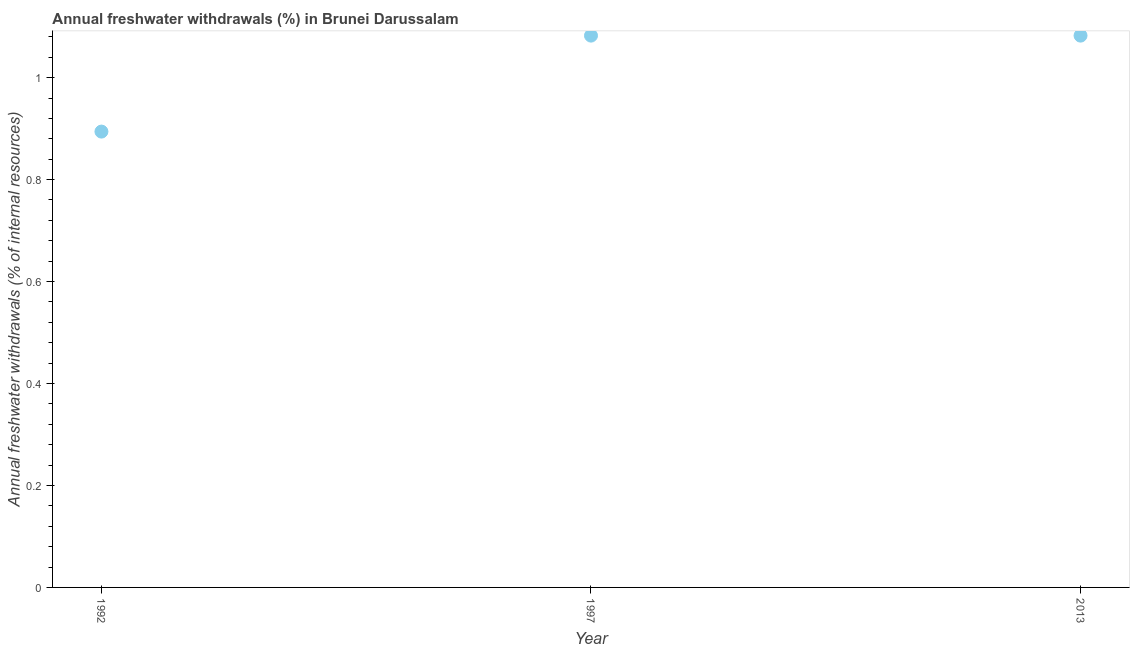What is the annual freshwater withdrawals in 1997?
Your answer should be compact. 1.08. Across all years, what is the maximum annual freshwater withdrawals?
Provide a succinct answer. 1.08. Across all years, what is the minimum annual freshwater withdrawals?
Your answer should be compact. 0.89. In which year was the annual freshwater withdrawals minimum?
Ensure brevity in your answer.  1992. What is the sum of the annual freshwater withdrawals?
Keep it short and to the point. 3.06. What is the difference between the annual freshwater withdrawals in 1992 and 1997?
Your answer should be compact. -0.19. What is the average annual freshwater withdrawals per year?
Your response must be concise. 1.02. What is the median annual freshwater withdrawals?
Your response must be concise. 1.08. In how many years, is the annual freshwater withdrawals greater than 0.6000000000000001 %?
Keep it short and to the point. 3. What is the ratio of the annual freshwater withdrawals in 1997 to that in 2013?
Keep it short and to the point. 1. Is the annual freshwater withdrawals in 1992 less than that in 1997?
Provide a short and direct response. Yes. Is the difference between the annual freshwater withdrawals in 1997 and 2013 greater than the difference between any two years?
Offer a terse response. No. What is the difference between the highest and the second highest annual freshwater withdrawals?
Keep it short and to the point. 0. Is the sum of the annual freshwater withdrawals in 1992 and 2013 greater than the maximum annual freshwater withdrawals across all years?
Ensure brevity in your answer.  Yes. What is the difference between the highest and the lowest annual freshwater withdrawals?
Make the answer very short. 0.19. Does the annual freshwater withdrawals monotonically increase over the years?
Offer a very short reply. No. How many years are there in the graph?
Keep it short and to the point. 3. What is the difference between two consecutive major ticks on the Y-axis?
Make the answer very short. 0.2. Are the values on the major ticks of Y-axis written in scientific E-notation?
Your answer should be compact. No. Does the graph contain grids?
Your response must be concise. No. What is the title of the graph?
Give a very brief answer. Annual freshwater withdrawals (%) in Brunei Darussalam. What is the label or title of the Y-axis?
Your answer should be compact. Annual freshwater withdrawals (% of internal resources). What is the Annual freshwater withdrawals (% of internal resources) in 1992?
Your answer should be compact. 0.89. What is the Annual freshwater withdrawals (% of internal resources) in 1997?
Give a very brief answer. 1.08. What is the Annual freshwater withdrawals (% of internal resources) in 2013?
Keep it short and to the point. 1.08. What is the difference between the Annual freshwater withdrawals (% of internal resources) in 1992 and 1997?
Make the answer very short. -0.19. What is the difference between the Annual freshwater withdrawals (% of internal resources) in 1992 and 2013?
Your response must be concise. -0.19. What is the ratio of the Annual freshwater withdrawals (% of internal resources) in 1992 to that in 1997?
Give a very brief answer. 0.83. What is the ratio of the Annual freshwater withdrawals (% of internal resources) in 1992 to that in 2013?
Your response must be concise. 0.83. 